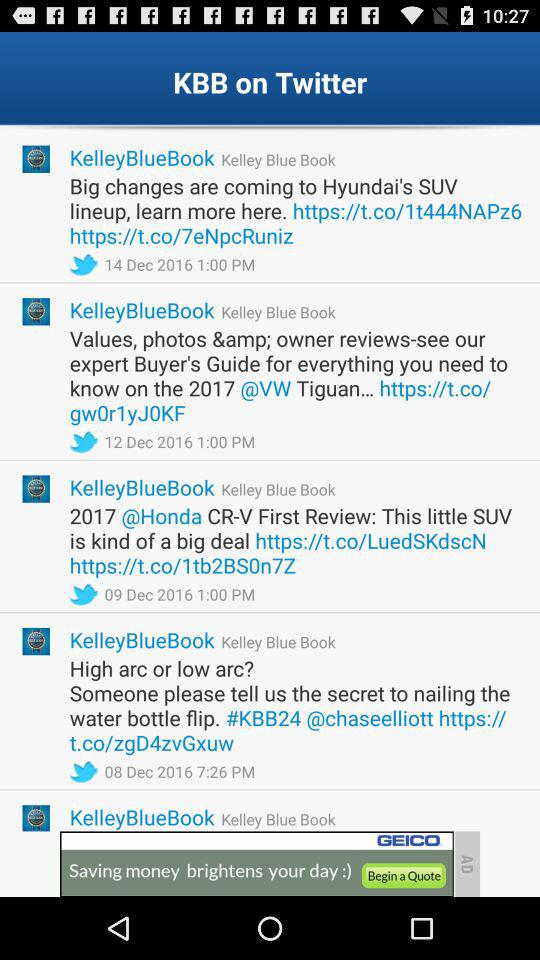What is the full form of MSRP? The full form of MSRP is "Manufacturer's Suggested Retail Price". 